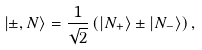<formula> <loc_0><loc_0><loc_500><loc_500>\left | { \pm , N } \right \rangle = \frac { 1 } { \sqrt { 2 } } \left ( { \left | { N _ { + } } \right \rangle \pm \left | { N _ { - } } \right \rangle } \right ) ,</formula> 